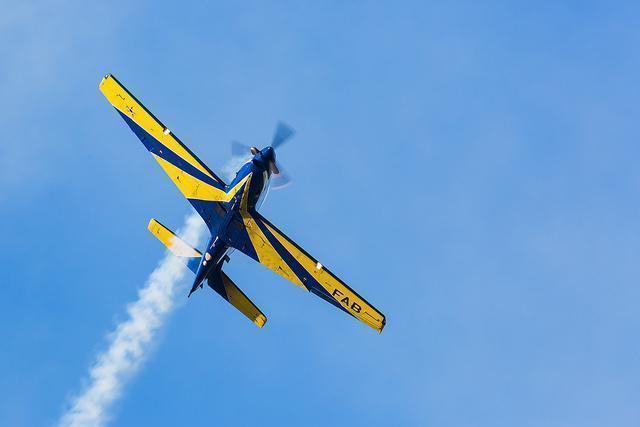How many umbrellas in this picture are yellow?
Give a very brief answer. 0. 